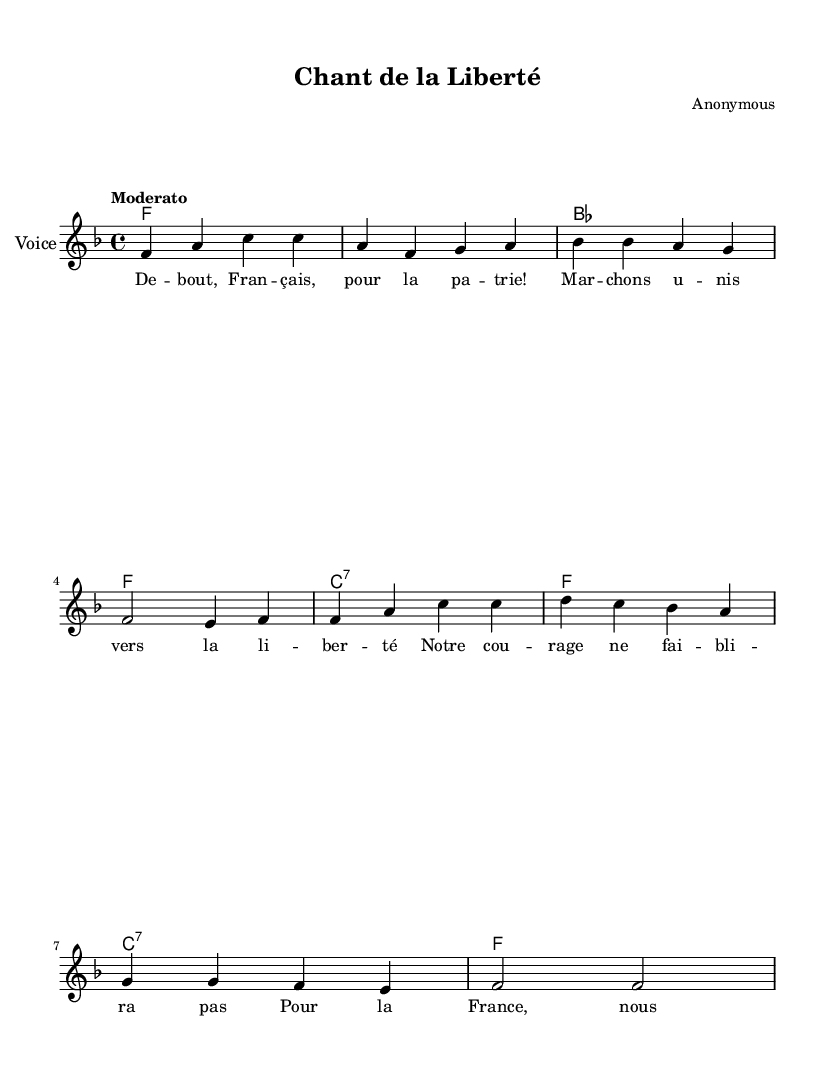What is the key signature of this music? The key signature indicates that the piece is in F major, as it has one flat (B flat). This is determined by looking at the key signature indicated at the beginning of the staff, where the flat symbol is located.
Answer: F major What is the time signature of this music? The time signature shown at the beginning is 4/4, which means there are four beats in each measure and the quarter note gets one beat. This can be identified by the numbers located at the start of the score, above the clef.
Answer: 4/4 What tempo marking is used for this music? The tempo marking "Moderato" is provided above the staff, indicating a moderate tempo. This term is common in music to denote a speed that is neither too slow nor too fast. You can find this tempo indication before the musical notation begins.
Answer: Moderato How many measures are present in the melody? The melody consists of eight measures, which can be determined by counting the vertical lines separating the sections of music (bars). Each complete set of notes between two vertical lines counts as one measure.
Answer: Eight Who is the composer of this piece? The composer is marked as "Anonymous" in the header section of the sheet music, which indicates that the authorship of the piece is unknown or not attributed to a specific person.
Answer: Anonymous What is the main theme of the lyrics? The lyrics express themes of bravery and patriotism, encapsulating the spirit of fighting for freedom and representing the country, which can be inferred from phrases in the text that emphasize courage and commitment for France. Analyzing the text helps in understanding its message.
Answer: Bravery and patriotism What type of music is this piece classified as? This piece is classified as a traditional French Resistance song, recognized by its historical context and its musical characteristics that evoke sentiments of courage and national pride during a turbulent time.
Answer: Traditional French Resistance song 